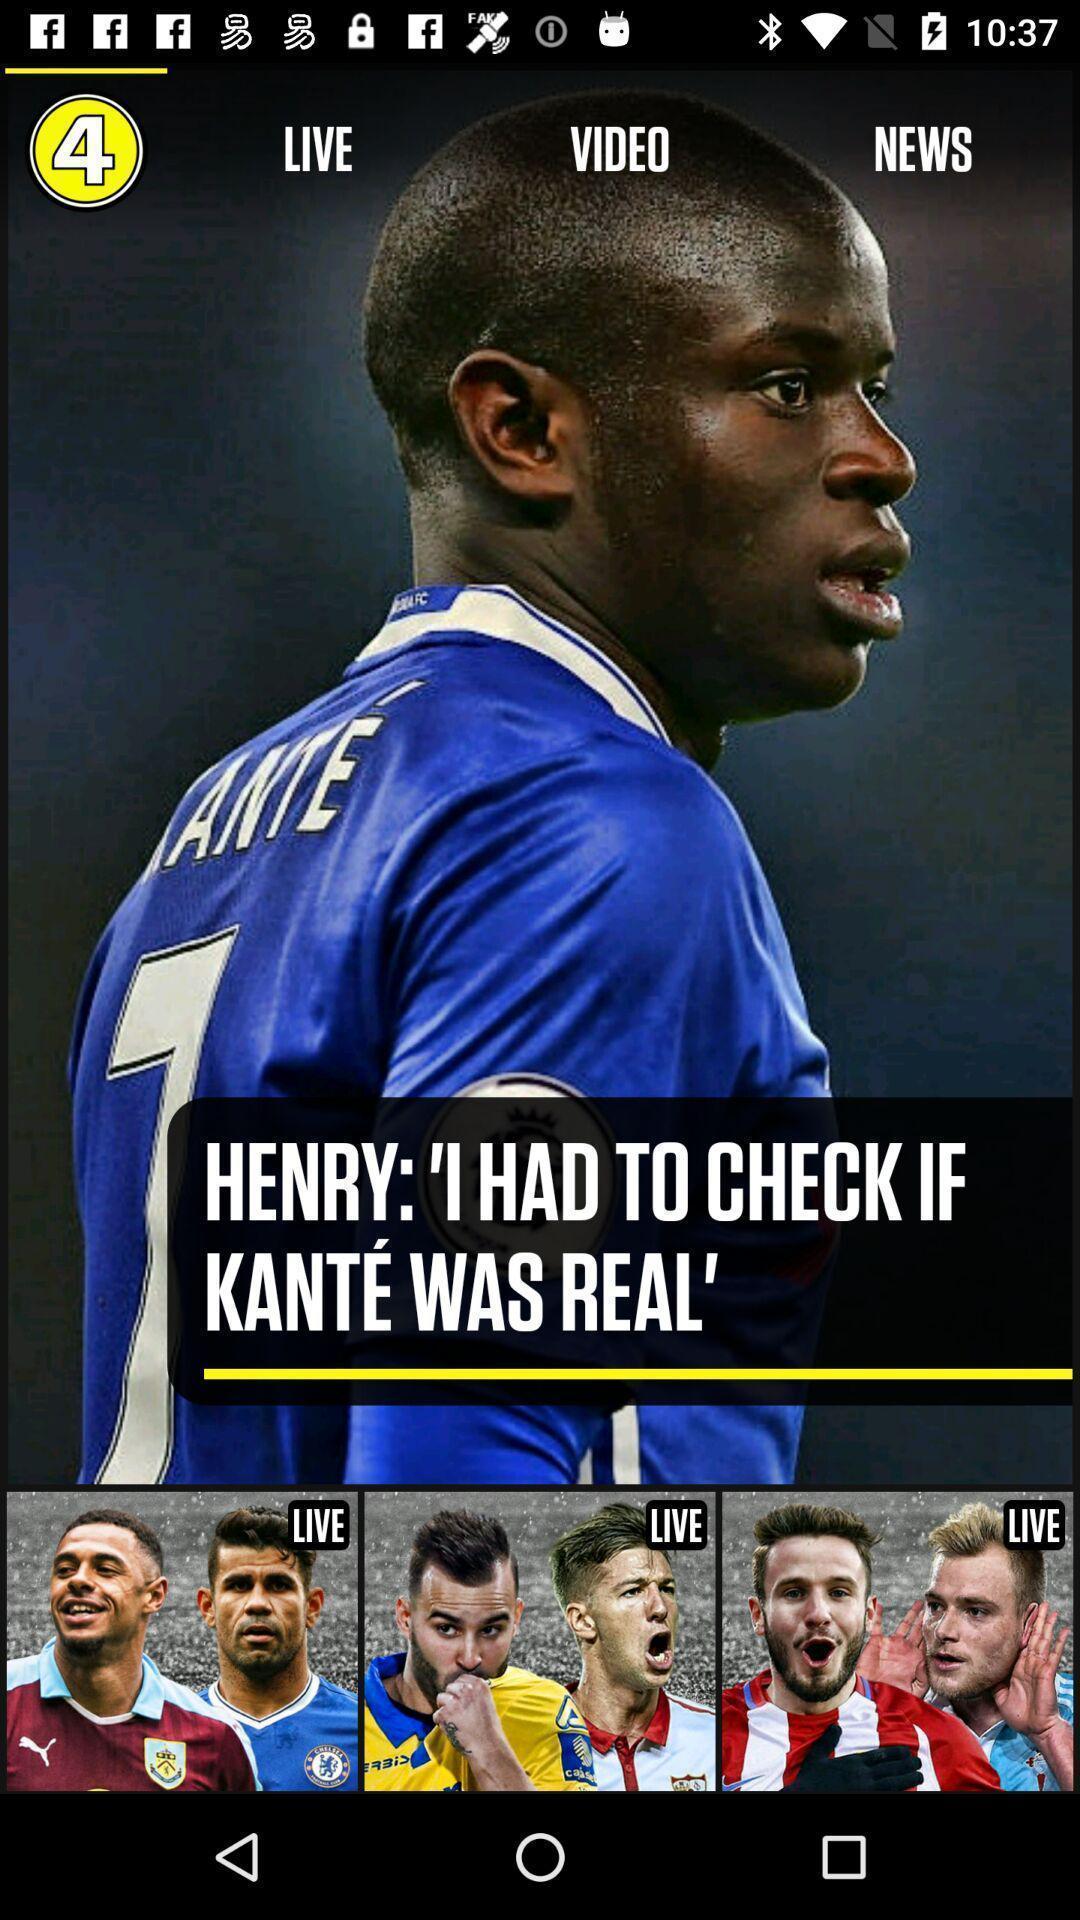Summarize the information in this screenshot. Screen page displaying sport update. 